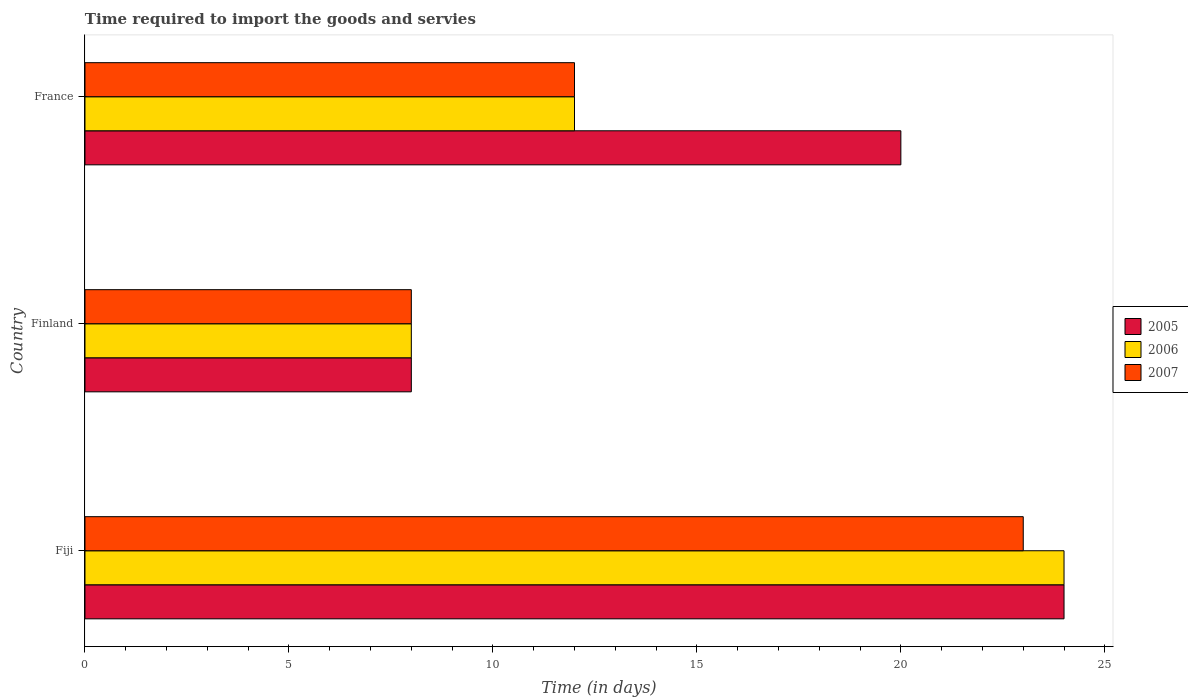How many different coloured bars are there?
Offer a terse response. 3. How many groups of bars are there?
Your response must be concise. 3. Are the number of bars per tick equal to the number of legend labels?
Ensure brevity in your answer.  Yes. Are the number of bars on each tick of the Y-axis equal?
Your answer should be compact. Yes. How many bars are there on the 2nd tick from the top?
Make the answer very short. 3. How many bars are there on the 1st tick from the bottom?
Your answer should be compact. 3. What is the label of the 2nd group of bars from the top?
Your answer should be compact. Finland. What is the number of days required to import the goods and services in 2005 in Finland?
Offer a very short reply. 8. In which country was the number of days required to import the goods and services in 2005 maximum?
Provide a succinct answer. Fiji. In which country was the number of days required to import the goods and services in 2005 minimum?
Give a very brief answer. Finland. What is the total number of days required to import the goods and services in 2007 in the graph?
Your response must be concise. 43. What is the difference between the number of days required to import the goods and services in 2007 in Fiji and the number of days required to import the goods and services in 2005 in Finland?
Your answer should be very brief. 15. What is the average number of days required to import the goods and services in 2005 per country?
Your answer should be compact. 17.33. What is the difference between the number of days required to import the goods and services in 2007 and number of days required to import the goods and services in 2006 in France?
Your answer should be compact. 0. What is the ratio of the number of days required to import the goods and services in 2005 in Fiji to that in France?
Your answer should be compact. 1.2. Is the difference between the number of days required to import the goods and services in 2007 in Finland and France greater than the difference between the number of days required to import the goods and services in 2006 in Finland and France?
Your answer should be compact. No. What is the difference between the highest and the lowest number of days required to import the goods and services in 2006?
Ensure brevity in your answer.  16. Is the sum of the number of days required to import the goods and services in 2005 in Fiji and France greater than the maximum number of days required to import the goods and services in 2006 across all countries?
Give a very brief answer. Yes. What does the 3rd bar from the top in Finland represents?
Offer a very short reply. 2005. Is it the case that in every country, the sum of the number of days required to import the goods and services in 2006 and number of days required to import the goods and services in 2007 is greater than the number of days required to import the goods and services in 2005?
Keep it short and to the point. Yes. Are all the bars in the graph horizontal?
Your response must be concise. Yes. Are the values on the major ticks of X-axis written in scientific E-notation?
Ensure brevity in your answer.  No. Does the graph contain grids?
Make the answer very short. No. Where does the legend appear in the graph?
Offer a terse response. Center right. How are the legend labels stacked?
Ensure brevity in your answer.  Vertical. What is the title of the graph?
Your answer should be compact. Time required to import the goods and servies. What is the label or title of the X-axis?
Provide a succinct answer. Time (in days). What is the label or title of the Y-axis?
Ensure brevity in your answer.  Country. What is the Time (in days) in 2005 in Fiji?
Provide a short and direct response. 24. What is the Time (in days) of 2006 in Fiji?
Your response must be concise. 24. Across all countries, what is the maximum Time (in days) of 2005?
Make the answer very short. 24. Across all countries, what is the maximum Time (in days) in 2006?
Ensure brevity in your answer.  24. Across all countries, what is the maximum Time (in days) of 2007?
Provide a short and direct response. 23. Across all countries, what is the minimum Time (in days) in 2005?
Give a very brief answer. 8. Across all countries, what is the minimum Time (in days) of 2007?
Offer a terse response. 8. What is the difference between the Time (in days) of 2007 in Fiji and that in Finland?
Your answer should be compact. 15. What is the difference between the Time (in days) of 2006 in Fiji and that in France?
Keep it short and to the point. 12. What is the difference between the Time (in days) of 2007 in Fiji and that in France?
Offer a very short reply. 11. What is the difference between the Time (in days) of 2006 in Finland and that in France?
Keep it short and to the point. -4. What is the difference between the Time (in days) in 2006 in Fiji and the Time (in days) in 2007 in Finland?
Give a very brief answer. 16. What is the difference between the Time (in days) of 2005 in Fiji and the Time (in days) of 2006 in France?
Provide a succinct answer. 12. What is the difference between the Time (in days) in 2005 in Finland and the Time (in days) in 2006 in France?
Your response must be concise. -4. What is the average Time (in days) of 2005 per country?
Keep it short and to the point. 17.33. What is the average Time (in days) in 2006 per country?
Provide a succinct answer. 14.67. What is the average Time (in days) in 2007 per country?
Offer a very short reply. 14.33. What is the difference between the Time (in days) in 2005 and Time (in days) in 2006 in Fiji?
Provide a succinct answer. 0. What is the difference between the Time (in days) of 2005 and Time (in days) of 2007 in Fiji?
Make the answer very short. 1. What is the difference between the Time (in days) in 2006 and Time (in days) in 2007 in Fiji?
Your answer should be very brief. 1. What is the difference between the Time (in days) in 2005 and Time (in days) in 2006 in France?
Your response must be concise. 8. What is the difference between the Time (in days) in 2006 and Time (in days) in 2007 in France?
Your response must be concise. 0. What is the ratio of the Time (in days) of 2005 in Fiji to that in Finland?
Provide a succinct answer. 3. What is the ratio of the Time (in days) of 2006 in Fiji to that in Finland?
Your response must be concise. 3. What is the ratio of the Time (in days) in 2007 in Fiji to that in Finland?
Your answer should be very brief. 2.88. What is the ratio of the Time (in days) of 2005 in Fiji to that in France?
Your answer should be very brief. 1.2. What is the ratio of the Time (in days) of 2006 in Fiji to that in France?
Provide a short and direct response. 2. What is the ratio of the Time (in days) in 2007 in Fiji to that in France?
Your answer should be compact. 1.92. What is the ratio of the Time (in days) of 2005 in Finland to that in France?
Provide a succinct answer. 0.4. What is the difference between the highest and the second highest Time (in days) of 2007?
Your answer should be compact. 11. What is the difference between the highest and the lowest Time (in days) of 2005?
Ensure brevity in your answer.  16. What is the difference between the highest and the lowest Time (in days) of 2006?
Your answer should be very brief. 16. 